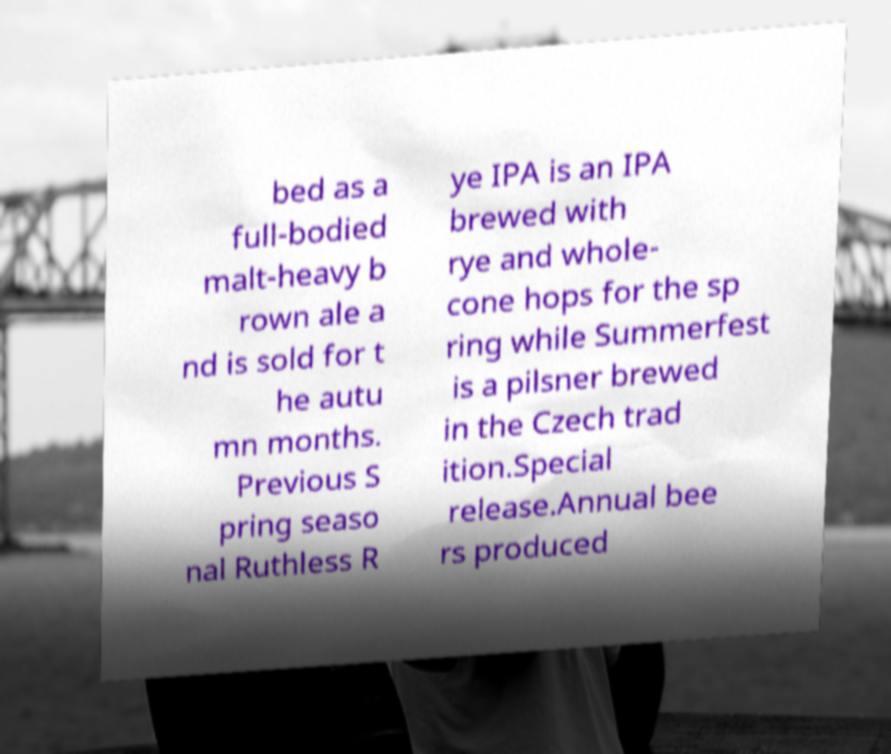Please identify and transcribe the text found in this image. bed as a full-bodied malt-heavy b rown ale a nd is sold for t he autu mn months. Previous S pring seaso nal Ruthless R ye IPA is an IPA brewed with rye and whole- cone hops for the sp ring while Summerfest is a pilsner brewed in the Czech trad ition.Special release.Annual bee rs produced 